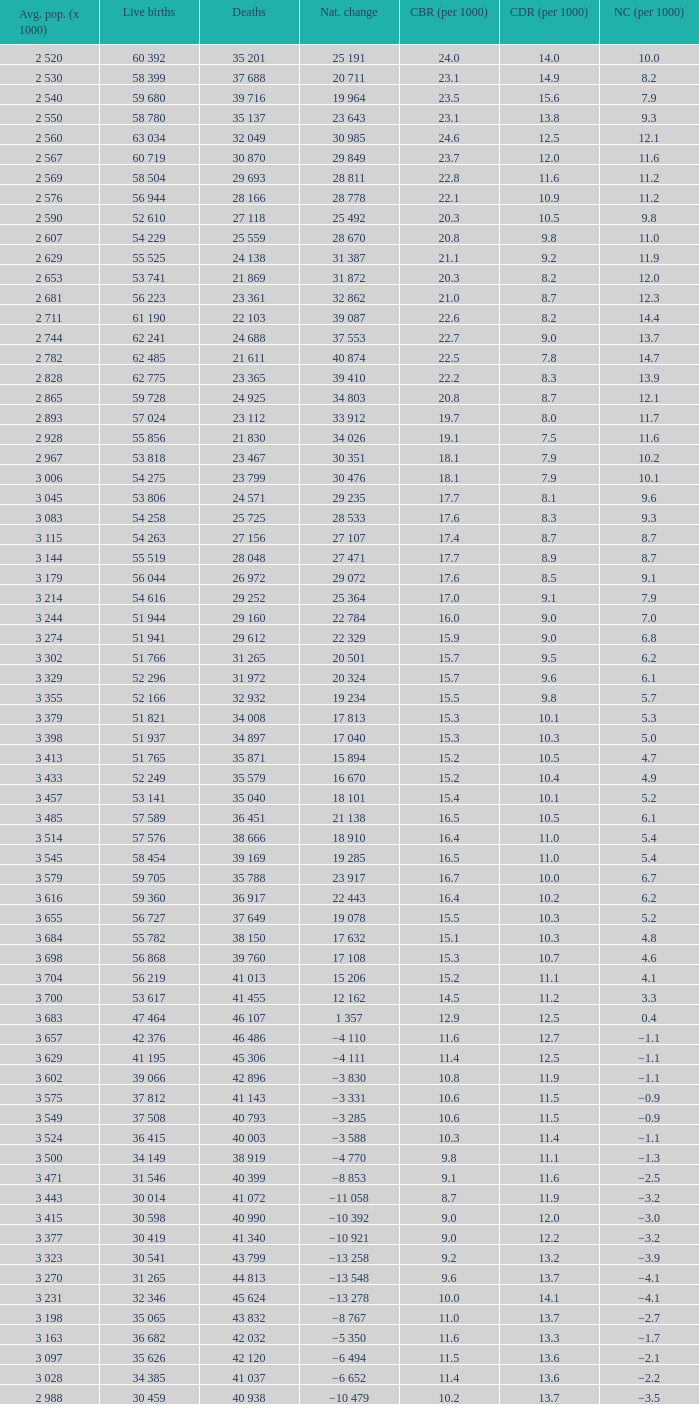Which Natural change has a Crude death rate (per 1000) larger than 9, and Deaths of 40 399? −8 853. 